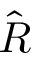Convert formula to latex. <formula><loc_0><loc_0><loc_500><loc_500>\hat { R }</formula> 